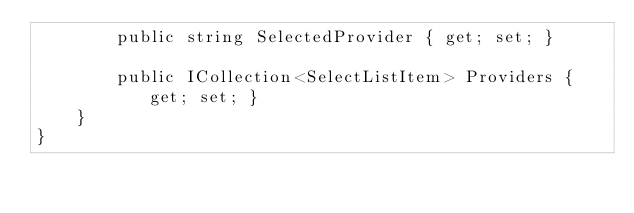Convert code to text. <code><loc_0><loc_0><loc_500><loc_500><_C#_>        public string SelectedProvider { get; set; }

        public ICollection<SelectListItem> Providers { get; set; }
    }
}
</code> 